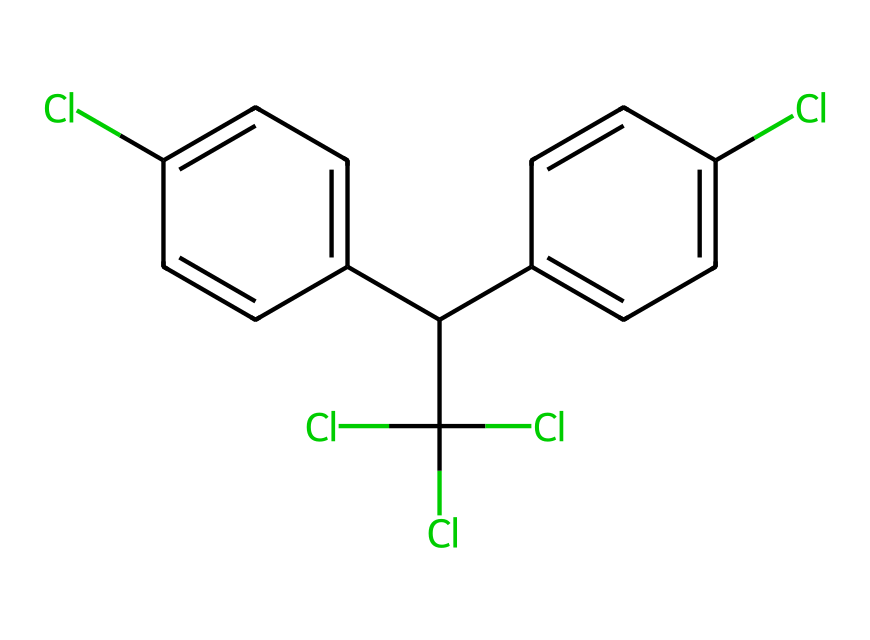What is the molecular formula of DDT? To determine the molecular formula, we count the number of each type of atom in the SMILES representation: there are 14 carbons (C), 9 hydrogens (H), and 5 chlorines (Cl). Therefore, the formula is C14H9Cl5.
Answer: C14H9Cl5 How many chlorine atoms are present in DDT? By examining the structure represented in the SMILES notation, we see there are five chlorine (Cl) atoms attached to the carbon atoms in the molecule.
Answer: 5 How many rings are present in the structure of DDT? In the SMILES representation, we can identify two aromatic rings indicated by the presence of 'c' for aromatic carbon in a cyclic structure. Both rings are connected to a carbon in the aliphatic chain.
Answer: 2 What is the primary functional group in DDT? The presence of multiple chlorine atoms indicates that the primary functional group is chloro, characterizing it as a chlorinated hydrocarbon, which is common in pesticides.
Answer: chloro What type of pesticide is DDT? DDT is classified as an organochlorine insecticide, as it contains chlorine atoms and has been used historically for pest control, notably malaria mosquitoes.
Answer: organochlorine How many aromatic carbons are in the chemical structure of DDT? By analyzing the SMILES string, we find that there are six aromatic carbon atoms in the two phenyl rings, which are part of the structure.
Answer: 6 What is the significance of the chlorine atoms in DDT's activity? The chlorine atoms in DDT enhance its lipophilicity, which is crucial for the pesticide's ability to penetrate lipid membranes in insects, making it an effective insecticide.
Answer: lipophilicity 